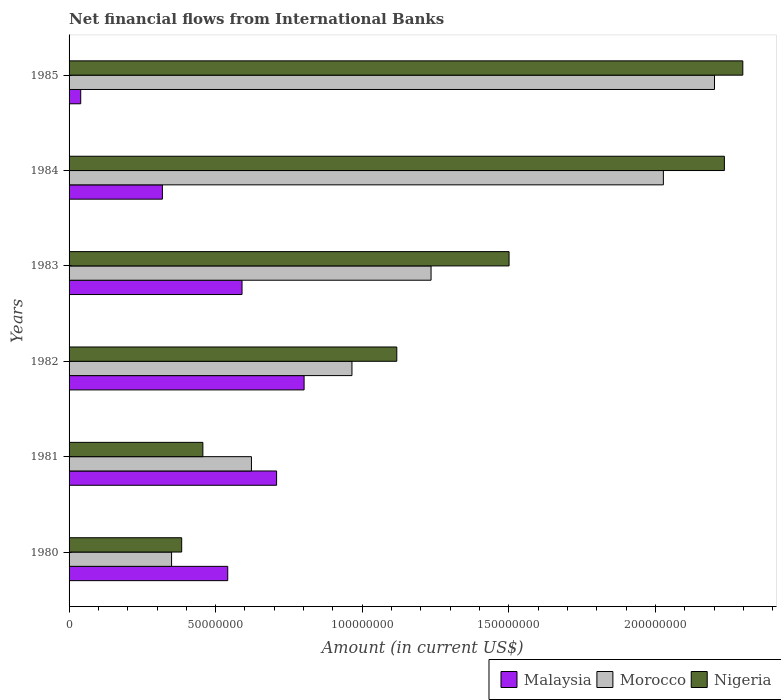How many different coloured bars are there?
Your answer should be compact. 3. How many groups of bars are there?
Offer a very short reply. 6. What is the label of the 6th group of bars from the top?
Your response must be concise. 1980. What is the net financial aid flows in Morocco in 1985?
Make the answer very short. 2.20e+08. Across all years, what is the maximum net financial aid flows in Malaysia?
Provide a succinct answer. 8.02e+07. Across all years, what is the minimum net financial aid flows in Nigeria?
Your answer should be compact. 3.84e+07. What is the total net financial aid flows in Nigeria in the graph?
Your response must be concise. 7.99e+08. What is the difference between the net financial aid flows in Nigeria in 1980 and that in 1981?
Your answer should be compact. -7.23e+06. What is the difference between the net financial aid flows in Nigeria in 1984 and the net financial aid flows in Morocco in 1982?
Provide a short and direct response. 1.27e+08. What is the average net financial aid flows in Malaysia per year?
Provide a short and direct response. 5.00e+07. In the year 1981, what is the difference between the net financial aid flows in Morocco and net financial aid flows in Nigeria?
Your answer should be very brief. 1.66e+07. In how many years, is the net financial aid flows in Malaysia greater than 180000000 US$?
Ensure brevity in your answer.  0. What is the ratio of the net financial aid flows in Malaysia in 1982 to that in 1983?
Your response must be concise. 1.36. What is the difference between the highest and the second highest net financial aid flows in Nigeria?
Make the answer very short. 6.28e+06. What is the difference between the highest and the lowest net financial aid flows in Malaysia?
Offer a terse response. 7.62e+07. In how many years, is the net financial aid flows in Nigeria greater than the average net financial aid flows in Nigeria taken over all years?
Offer a terse response. 3. Is the sum of the net financial aid flows in Malaysia in 1980 and 1981 greater than the maximum net financial aid flows in Morocco across all years?
Ensure brevity in your answer.  No. What does the 3rd bar from the top in 1984 represents?
Your answer should be compact. Malaysia. What does the 2nd bar from the bottom in 1981 represents?
Ensure brevity in your answer.  Morocco. Is it the case that in every year, the sum of the net financial aid flows in Morocco and net financial aid flows in Nigeria is greater than the net financial aid flows in Malaysia?
Ensure brevity in your answer.  Yes. How many bars are there?
Your response must be concise. 18. What is the difference between two consecutive major ticks on the X-axis?
Your response must be concise. 5.00e+07. Where does the legend appear in the graph?
Offer a terse response. Bottom right. How many legend labels are there?
Give a very brief answer. 3. What is the title of the graph?
Your response must be concise. Net financial flows from International Banks. Does "Australia" appear as one of the legend labels in the graph?
Give a very brief answer. No. What is the Amount (in current US$) of Malaysia in 1980?
Your answer should be compact. 5.41e+07. What is the Amount (in current US$) of Morocco in 1980?
Provide a short and direct response. 3.50e+07. What is the Amount (in current US$) of Nigeria in 1980?
Ensure brevity in your answer.  3.84e+07. What is the Amount (in current US$) in Malaysia in 1981?
Your answer should be very brief. 7.08e+07. What is the Amount (in current US$) of Morocco in 1981?
Your answer should be very brief. 6.22e+07. What is the Amount (in current US$) in Nigeria in 1981?
Your response must be concise. 4.56e+07. What is the Amount (in current US$) in Malaysia in 1982?
Give a very brief answer. 8.02e+07. What is the Amount (in current US$) of Morocco in 1982?
Your response must be concise. 9.65e+07. What is the Amount (in current US$) in Nigeria in 1982?
Offer a terse response. 1.12e+08. What is the Amount (in current US$) in Malaysia in 1983?
Offer a very short reply. 5.90e+07. What is the Amount (in current US$) in Morocco in 1983?
Your answer should be very brief. 1.23e+08. What is the Amount (in current US$) of Nigeria in 1983?
Make the answer very short. 1.50e+08. What is the Amount (in current US$) of Malaysia in 1984?
Provide a succinct answer. 3.18e+07. What is the Amount (in current US$) in Morocco in 1984?
Provide a succinct answer. 2.03e+08. What is the Amount (in current US$) of Nigeria in 1984?
Give a very brief answer. 2.24e+08. What is the Amount (in current US$) in Malaysia in 1985?
Provide a succinct answer. 3.97e+06. What is the Amount (in current US$) of Morocco in 1985?
Ensure brevity in your answer.  2.20e+08. What is the Amount (in current US$) of Nigeria in 1985?
Your answer should be compact. 2.30e+08. Across all years, what is the maximum Amount (in current US$) of Malaysia?
Your answer should be compact. 8.02e+07. Across all years, what is the maximum Amount (in current US$) of Morocco?
Your response must be concise. 2.20e+08. Across all years, what is the maximum Amount (in current US$) in Nigeria?
Offer a terse response. 2.30e+08. Across all years, what is the minimum Amount (in current US$) of Malaysia?
Your response must be concise. 3.97e+06. Across all years, what is the minimum Amount (in current US$) of Morocco?
Give a very brief answer. 3.50e+07. Across all years, what is the minimum Amount (in current US$) in Nigeria?
Offer a terse response. 3.84e+07. What is the total Amount (in current US$) in Malaysia in the graph?
Keep it short and to the point. 3.00e+08. What is the total Amount (in current US$) in Morocco in the graph?
Provide a short and direct response. 7.40e+08. What is the total Amount (in current US$) of Nigeria in the graph?
Provide a succinct answer. 7.99e+08. What is the difference between the Amount (in current US$) in Malaysia in 1980 and that in 1981?
Offer a very short reply. -1.67e+07. What is the difference between the Amount (in current US$) in Morocco in 1980 and that in 1981?
Offer a very short reply. -2.72e+07. What is the difference between the Amount (in current US$) of Nigeria in 1980 and that in 1981?
Give a very brief answer. -7.23e+06. What is the difference between the Amount (in current US$) in Malaysia in 1980 and that in 1982?
Give a very brief answer. -2.61e+07. What is the difference between the Amount (in current US$) of Morocco in 1980 and that in 1982?
Provide a short and direct response. -6.15e+07. What is the difference between the Amount (in current US$) in Nigeria in 1980 and that in 1982?
Keep it short and to the point. -7.34e+07. What is the difference between the Amount (in current US$) of Malaysia in 1980 and that in 1983?
Provide a short and direct response. -4.88e+06. What is the difference between the Amount (in current US$) in Morocco in 1980 and that in 1983?
Provide a short and direct response. -8.85e+07. What is the difference between the Amount (in current US$) in Nigeria in 1980 and that in 1983?
Your answer should be very brief. -1.12e+08. What is the difference between the Amount (in current US$) in Malaysia in 1980 and that in 1984?
Offer a very short reply. 2.23e+07. What is the difference between the Amount (in current US$) of Morocco in 1980 and that in 1984?
Keep it short and to the point. -1.68e+08. What is the difference between the Amount (in current US$) of Nigeria in 1980 and that in 1984?
Your response must be concise. -1.85e+08. What is the difference between the Amount (in current US$) of Malaysia in 1980 and that in 1985?
Provide a short and direct response. 5.01e+07. What is the difference between the Amount (in current US$) of Morocco in 1980 and that in 1985?
Provide a short and direct response. -1.85e+08. What is the difference between the Amount (in current US$) of Nigeria in 1980 and that in 1985?
Keep it short and to the point. -1.91e+08. What is the difference between the Amount (in current US$) of Malaysia in 1981 and that in 1982?
Provide a succinct answer. -9.38e+06. What is the difference between the Amount (in current US$) in Morocco in 1981 and that in 1982?
Provide a short and direct response. -3.43e+07. What is the difference between the Amount (in current US$) of Nigeria in 1981 and that in 1982?
Offer a terse response. -6.62e+07. What is the difference between the Amount (in current US$) in Malaysia in 1981 and that in 1983?
Ensure brevity in your answer.  1.18e+07. What is the difference between the Amount (in current US$) of Morocco in 1981 and that in 1983?
Give a very brief answer. -6.13e+07. What is the difference between the Amount (in current US$) of Nigeria in 1981 and that in 1983?
Ensure brevity in your answer.  -1.04e+08. What is the difference between the Amount (in current US$) in Malaysia in 1981 and that in 1984?
Offer a very short reply. 3.90e+07. What is the difference between the Amount (in current US$) of Morocco in 1981 and that in 1984?
Keep it short and to the point. -1.41e+08. What is the difference between the Amount (in current US$) in Nigeria in 1981 and that in 1984?
Your answer should be compact. -1.78e+08. What is the difference between the Amount (in current US$) of Malaysia in 1981 and that in 1985?
Provide a short and direct response. 6.68e+07. What is the difference between the Amount (in current US$) in Morocco in 1981 and that in 1985?
Keep it short and to the point. -1.58e+08. What is the difference between the Amount (in current US$) in Nigeria in 1981 and that in 1985?
Offer a very short reply. -1.84e+08. What is the difference between the Amount (in current US$) in Malaysia in 1982 and that in 1983?
Provide a succinct answer. 2.12e+07. What is the difference between the Amount (in current US$) in Morocco in 1982 and that in 1983?
Your answer should be compact. -2.70e+07. What is the difference between the Amount (in current US$) in Nigeria in 1982 and that in 1983?
Your answer should be very brief. -3.83e+07. What is the difference between the Amount (in current US$) in Malaysia in 1982 and that in 1984?
Ensure brevity in your answer.  4.83e+07. What is the difference between the Amount (in current US$) of Morocco in 1982 and that in 1984?
Make the answer very short. -1.06e+08. What is the difference between the Amount (in current US$) in Nigeria in 1982 and that in 1984?
Offer a very short reply. -1.12e+08. What is the difference between the Amount (in current US$) of Malaysia in 1982 and that in 1985?
Provide a short and direct response. 7.62e+07. What is the difference between the Amount (in current US$) of Morocco in 1982 and that in 1985?
Offer a very short reply. -1.24e+08. What is the difference between the Amount (in current US$) of Nigeria in 1982 and that in 1985?
Give a very brief answer. -1.18e+08. What is the difference between the Amount (in current US$) of Malaysia in 1983 and that in 1984?
Ensure brevity in your answer.  2.72e+07. What is the difference between the Amount (in current US$) in Morocco in 1983 and that in 1984?
Keep it short and to the point. -7.92e+07. What is the difference between the Amount (in current US$) of Nigeria in 1983 and that in 1984?
Give a very brief answer. -7.35e+07. What is the difference between the Amount (in current US$) in Malaysia in 1983 and that in 1985?
Give a very brief answer. 5.50e+07. What is the difference between the Amount (in current US$) in Morocco in 1983 and that in 1985?
Ensure brevity in your answer.  -9.67e+07. What is the difference between the Amount (in current US$) in Nigeria in 1983 and that in 1985?
Make the answer very short. -7.97e+07. What is the difference between the Amount (in current US$) of Malaysia in 1984 and that in 1985?
Keep it short and to the point. 2.79e+07. What is the difference between the Amount (in current US$) in Morocco in 1984 and that in 1985?
Keep it short and to the point. -1.74e+07. What is the difference between the Amount (in current US$) in Nigeria in 1984 and that in 1985?
Your response must be concise. -6.28e+06. What is the difference between the Amount (in current US$) of Malaysia in 1980 and the Amount (in current US$) of Morocco in 1981?
Your answer should be compact. -8.09e+06. What is the difference between the Amount (in current US$) of Malaysia in 1980 and the Amount (in current US$) of Nigeria in 1981?
Provide a short and direct response. 8.48e+06. What is the difference between the Amount (in current US$) of Morocco in 1980 and the Amount (in current US$) of Nigeria in 1981?
Your answer should be very brief. -1.07e+07. What is the difference between the Amount (in current US$) in Malaysia in 1980 and the Amount (in current US$) in Morocco in 1982?
Make the answer very short. -4.24e+07. What is the difference between the Amount (in current US$) of Malaysia in 1980 and the Amount (in current US$) of Nigeria in 1982?
Keep it short and to the point. -5.77e+07. What is the difference between the Amount (in current US$) in Morocco in 1980 and the Amount (in current US$) in Nigeria in 1982?
Provide a succinct answer. -7.68e+07. What is the difference between the Amount (in current US$) of Malaysia in 1980 and the Amount (in current US$) of Morocco in 1983?
Provide a succinct answer. -6.94e+07. What is the difference between the Amount (in current US$) in Malaysia in 1980 and the Amount (in current US$) in Nigeria in 1983?
Keep it short and to the point. -9.60e+07. What is the difference between the Amount (in current US$) of Morocco in 1980 and the Amount (in current US$) of Nigeria in 1983?
Give a very brief answer. -1.15e+08. What is the difference between the Amount (in current US$) in Malaysia in 1980 and the Amount (in current US$) in Morocco in 1984?
Make the answer very short. -1.49e+08. What is the difference between the Amount (in current US$) of Malaysia in 1980 and the Amount (in current US$) of Nigeria in 1984?
Provide a succinct answer. -1.69e+08. What is the difference between the Amount (in current US$) of Morocco in 1980 and the Amount (in current US$) of Nigeria in 1984?
Offer a terse response. -1.89e+08. What is the difference between the Amount (in current US$) in Malaysia in 1980 and the Amount (in current US$) in Morocco in 1985?
Offer a very short reply. -1.66e+08. What is the difference between the Amount (in current US$) of Malaysia in 1980 and the Amount (in current US$) of Nigeria in 1985?
Your answer should be very brief. -1.76e+08. What is the difference between the Amount (in current US$) of Morocco in 1980 and the Amount (in current US$) of Nigeria in 1985?
Provide a short and direct response. -1.95e+08. What is the difference between the Amount (in current US$) of Malaysia in 1981 and the Amount (in current US$) of Morocco in 1982?
Your response must be concise. -2.57e+07. What is the difference between the Amount (in current US$) of Malaysia in 1981 and the Amount (in current US$) of Nigeria in 1982?
Keep it short and to the point. -4.10e+07. What is the difference between the Amount (in current US$) in Morocco in 1981 and the Amount (in current US$) in Nigeria in 1982?
Offer a terse response. -4.96e+07. What is the difference between the Amount (in current US$) in Malaysia in 1981 and the Amount (in current US$) in Morocco in 1983?
Give a very brief answer. -5.27e+07. What is the difference between the Amount (in current US$) in Malaysia in 1981 and the Amount (in current US$) in Nigeria in 1983?
Give a very brief answer. -7.93e+07. What is the difference between the Amount (in current US$) in Morocco in 1981 and the Amount (in current US$) in Nigeria in 1983?
Keep it short and to the point. -8.79e+07. What is the difference between the Amount (in current US$) in Malaysia in 1981 and the Amount (in current US$) in Morocco in 1984?
Your answer should be very brief. -1.32e+08. What is the difference between the Amount (in current US$) in Malaysia in 1981 and the Amount (in current US$) in Nigeria in 1984?
Offer a very short reply. -1.53e+08. What is the difference between the Amount (in current US$) of Morocco in 1981 and the Amount (in current US$) of Nigeria in 1984?
Provide a short and direct response. -1.61e+08. What is the difference between the Amount (in current US$) of Malaysia in 1981 and the Amount (in current US$) of Morocco in 1985?
Offer a terse response. -1.49e+08. What is the difference between the Amount (in current US$) in Malaysia in 1981 and the Amount (in current US$) in Nigeria in 1985?
Ensure brevity in your answer.  -1.59e+08. What is the difference between the Amount (in current US$) in Morocco in 1981 and the Amount (in current US$) in Nigeria in 1985?
Your response must be concise. -1.68e+08. What is the difference between the Amount (in current US$) in Malaysia in 1982 and the Amount (in current US$) in Morocco in 1983?
Your answer should be very brief. -4.33e+07. What is the difference between the Amount (in current US$) of Malaysia in 1982 and the Amount (in current US$) of Nigeria in 1983?
Offer a very short reply. -6.99e+07. What is the difference between the Amount (in current US$) of Morocco in 1982 and the Amount (in current US$) of Nigeria in 1983?
Your answer should be very brief. -5.36e+07. What is the difference between the Amount (in current US$) of Malaysia in 1982 and the Amount (in current US$) of Morocco in 1984?
Offer a terse response. -1.23e+08. What is the difference between the Amount (in current US$) in Malaysia in 1982 and the Amount (in current US$) in Nigeria in 1984?
Your answer should be compact. -1.43e+08. What is the difference between the Amount (in current US$) of Morocco in 1982 and the Amount (in current US$) of Nigeria in 1984?
Offer a very short reply. -1.27e+08. What is the difference between the Amount (in current US$) in Malaysia in 1982 and the Amount (in current US$) in Morocco in 1985?
Your answer should be compact. -1.40e+08. What is the difference between the Amount (in current US$) of Malaysia in 1982 and the Amount (in current US$) of Nigeria in 1985?
Give a very brief answer. -1.50e+08. What is the difference between the Amount (in current US$) of Morocco in 1982 and the Amount (in current US$) of Nigeria in 1985?
Ensure brevity in your answer.  -1.33e+08. What is the difference between the Amount (in current US$) in Malaysia in 1983 and the Amount (in current US$) in Morocco in 1984?
Your answer should be compact. -1.44e+08. What is the difference between the Amount (in current US$) of Malaysia in 1983 and the Amount (in current US$) of Nigeria in 1984?
Offer a terse response. -1.65e+08. What is the difference between the Amount (in current US$) in Morocco in 1983 and the Amount (in current US$) in Nigeria in 1984?
Offer a very short reply. -1.00e+08. What is the difference between the Amount (in current US$) in Malaysia in 1983 and the Amount (in current US$) in Morocco in 1985?
Your response must be concise. -1.61e+08. What is the difference between the Amount (in current US$) of Malaysia in 1983 and the Amount (in current US$) of Nigeria in 1985?
Ensure brevity in your answer.  -1.71e+08. What is the difference between the Amount (in current US$) of Morocco in 1983 and the Amount (in current US$) of Nigeria in 1985?
Offer a very short reply. -1.06e+08. What is the difference between the Amount (in current US$) of Malaysia in 1984 and the Amount (in current US$) of Morocco in 1985?
Your answer should be very brief. -1.88e+08. What is the difference between the Amount (in current US$) in Malaysia in 1984 and the Amount (in current US$) in Nigeria in 1985?
Give a very brief answer. -1.98e+08. What is the difference between the Amount (in current US$) of Morocco in 1984 and the Amount (in current US$) of Nigeria in 1985?
Provide a short and direct response. -2.71e+07. What is the average Amount (in current US$) in Malaysia per year?
Keep it short and to the point. 5.00e+07. What is the average Amount (in current US$) of Morocco per year?
Provide a succinct answer. 1.23e+08. What is the average Amount (in current US$) in Nigeria per year?
Provide a short and direct response. 1.33e+08. In the year 1980, what is the difference between the Amount (in current US$) of Malaysia and Amount (in current US$) of Morocco?
Offer a terse response. 1.92e+07. In the year 1980, what is the difference between the Amount (in current US$) of Malaysia and Amount (in current US$) of Nigeria?
Your answer should be very brief. 1.57e+07. In the year 1980, what is the difference between the Amount (in current US$) of Morocco and Amount (in current US$) of Nigeria?
Keep it short and to the point. -3.45e+06. In the year 1981, what is the difference between the Amount (in current US$) in Malaysia and Amount (in current US$) in Morocco?
Give a very brief answer. 8.57e+06. In the year 1981, what is the difference between the Amount (in current US$) of Malaysia and Amount (in current US$) of Nigeria?
Your answer should be compact. 2.51e+07. In the year 1981, what is the difference between the Amount (in current US$) of Morocco and Amount (in current US$) of Nigeria?
Offer a very short reply. 1.66e+07. In the year 1982, what is the difference between the Amount (in current US$) in Malaysia and Amount (in current US$) in Morocco?
Keep it short and to the point. -1.63e+07. In the year 1982, what is the difference between the Amount (in current US$) in Malaysia and Amount (in current US$) in Nigeria?
Ensure brevity in your answer.  -3.16e+07. In the year 1982, what is the difference between the Amount (in current US$) of Morocco and Amount (in current US$) of Nigeria?
Offer a terse response. -1.53e+07. In the year 1983, what is the difference between the Amount (in current US$) in Malaysia and Amount (in current US$) in Morocco?
Make the answer very short. -6.45e+07. In the year 1983, what is the difference between the Amount (in current US$) in Malaysia and Amount (in current US$) in Nigeria?
Offer a terse response. -9.11e+07. In the year 1983, what is the difference between the Amount (in current US$) of Morocco and Amount (in current US$) of Nigeria?
Provide a short and direct response. -2.66e+07. In the year 1984, what is the difference between the Amount (in current US$) of Malaysia and Amount (in current US$) of Morocco?
Ensure brevity in your answer.  -1.71e+08. In the year 1984, what is the difference between the Amount (in current US$) in Malaysia and Amount (in current US$) in Nigeria?
Your answer should be very brief. -1.92e+08. In the year 1984, what is the difference between the Amount (in current US$) in Morocco and Amount (in current US$) in Nigeria?
Provide a succinct answer. -2.08e+07. In the year 1985, what is the difference between the Amount (in current US$) of Malaysia and Amount (in current US$) of Morocco?
Give a very brief answer. -2.16e+08. In the year 1985, what is the difference between the Amount (in current US$) of Malaysia and Amount (in current US$) of Nigeria?
Provide a short and direct response. -2.26e+08. In the year 1985, what is the difference between the Amount (in current US$) in Morocco and Amount (in current US$) in Nigeria?
Give a very brief answer. -9.65e+06. What is the ratio of the Amount (in current US$) in Malaysia in 1980 to that in 1981?
Your response must be concise. 0.76. What is the ratio of the Amount (in current US$) in Morocco in 1980 to that in 1981?
Keep it short and to the point. 0.56. What is the ratio of the Amount (in current US$) in Nigeria in 1980 to that in 1981?
Provide a short and direct response. 0.84. What is the ratio of the Amount (in current US$) of Malaysia in 1980 to that in 1982?
Make the answer very short. 0.68. What is the ratio of the Amount (in current US$) of Morocco in 1980 to that in 1982?
Keep it short and to the point. 0.36. What is the ratio of the Amount (in current US$) of Nigeria in 1980 to that in 1982?
Offer a very short reply. 0.34. What is the ratio of the Amount (in current US$) in Malaysia in 1980 to that in 1983?
Keep it short and to the point. 0.92. What is the ratio of the Amount (in current US$) of Morocco in 1980 to that in 1983?
Offer a terse response. 0.28. What is the ratio of the Amount (in current US$) of Nigeria in 1980 to that in 1983?
Ensure brevity in your answer.  0.26. What is the ratio of the Amount (in current US$) of Morocco in 1980 to that in 1984?
Keep it short and to the point. 0.17. What is the ratio of the Amount (in current US$) of Nigeria in 1980 to that in 1984?
Your response must be concise. 0.17. What is the ratio of the Amount (in current US$) in Malaysia in 1980 to that in 1985?
Your answer should be compact. 13.62. What is the ratio of the Amount (in current US$) in Morocco in 1980 to that in 1985?
Keep it short and to the point. 0.16. What is the ratio of the Amount (in current US$) in Nigeria in 1980 to that in 1985?
Make the answer very short. 0.17. What is the ratio of the Amount (in current US$) of Malaysia in 1981 to that in 1982?
Your answer should be very brief. 0.88. What is the ratio of the Amount (in current US$) in Morocco in 1981 to that in 1982?
Ensure brevity in your answer.  0.64. What is the ratio of the Amount (in current US$) in Nigeria in 1981 to that in 1982?
Keep it short and to the point. 0.41. What is the ratio of the Amount (in current US$) of Malaysia in 1981 to that in 1983?
Offer a terse response. 1.2. What is the ratio of the Amount (in current US$) in Morocco in 1981 to that in 1983?
Provide a short and direct response. 0.5. What is the ratio of the Amount (in current US$) in Nigeria in 1981 to that in 1983?
Your answer should be compact. 0.3. What is the ratio of the Amount (in current US$) of Malaysia in 1981 to that in 1984?
Offer a terse response. 2.22. What is the ratio of the Amount (in current US$) in Morocco in 1981 to that in 1984?
Your answer should be very brief. 0.31. What is the ratio of the Amount (in current US$) of Nigeria in 1981 to that in 1984?
Provide a succinct answer. 0.2. What is the ratio of the Amount (in current US$) of Malaysia in 1981 to that in 1985?
Give a very brief answer. 17.81. What is the ratio of the Amount (in current US$) of Morocco in 1981 to that in 1985?
Give a very brief answer. 0.28. What is the ratio of the Amount (in current US$) in Nigeria in 1981 to that in 1985?
Give a very brief answer. 0.2. What is the ratio of the Amount (in current US$) in Malaysia in 1982 to that in 1983?
Provide a succinct answer. 1.36. What is the ratio of the Amount (in current US$) in Morocco in 1982 to that in 1983?
Provide a succinct answer. 0.78. What is the ratio of the Amount (in current US$) in Nigeria in 1982 to that in 1983?
Offer a very short reply. 0.74. What is the ratio of the Amount (in current US$) in Malaysia in 1982 to that in 1984?
Ensure brevity in your answer.  2.52. What is the ratio of the Amount (in current US$) in Morocco in 1982 to that in 1984?
Your answer should be very brief. 0.48. What is the ratio of the Amount (in current US$) of Nigeria in 1982 to that in 1984?
Keep it short and to the point. 0.5. What is the ratio of the Amount (in current US$) in Malaysia in 1982 to that in 1985?
Provide a short and direct response. 20.17. What is the ratio of the Amount (in current US$) of Morocco in 1982 to that in 1985?
Provide a short and direct response. 0.44. What is the ratio of the Amount (in current US$) in Nigeria in 1982 to that in 1985?
Provide a short and direct response. 0.49. What is the ratio of the Amount (in current US$) in Malaysia in 1983 to that in 1984?
Provide a succinct answer. 1.85. What is the ratio of the Amount (in current US$) of Morocco in 1983 to that in 1984?
Your answer should be very brief. 0.61. What is the ratio of the Amount (in current US$) in Nigeria in 1983 to that in 1984?
Make the answer very short. 0.67. What is the ratio of the Amount (in current US$) of Malaysia in 1983 to that in 1985?
Your answer should be compact. 14.85. What is the ratio of the Amount (in current US$) in Morocco in 1983 to that in 1985?
Provide a short and direct response. 0.56. What is the ratio of the Amount (in current US$) of Nigeria in 1983 to that in 1985?
Give a very brief answer. 0.65. What is the ratio of the Amount (in current US$) in Malaysia in 1984 to that in 1985?
Offer a terse response. 8.01. What is the ratio of the Amount (in current US$) of Morocco in 1984 to that in 1985?
Your answer should be compact. 0.92. What is the ratio of the Amount (in current US$) in Nigeria in 1984 to that in 1985?
Offer a very short reply. 0.97. What is the difference between the highest and the second highest Amount (in current US$) of Malaysia?
Provide a short and direct response. 9.38e+06. What is the difference between the highest and the second highest Amount (in current US$) of Morocco?
Make the answer very short. 1.74e+07. What is the difference between the highest and the second highest Amount (in current US$) in Nigeria?
Offer a very short reply. 6.28e+06. What is the difference between the highest and the lowest Amount (in current US$) in Malaysia?
Offer a terse response. 7.62e+07. What is the difference between the highest and the lowest Amount (in current US$) in Morocco?
Your response must be concise. 1.85e+08. What is the difference between the highest and the lowest Amount (in current US$) in Nigeria?
Keep it short and to the point. 1.91e+08. 